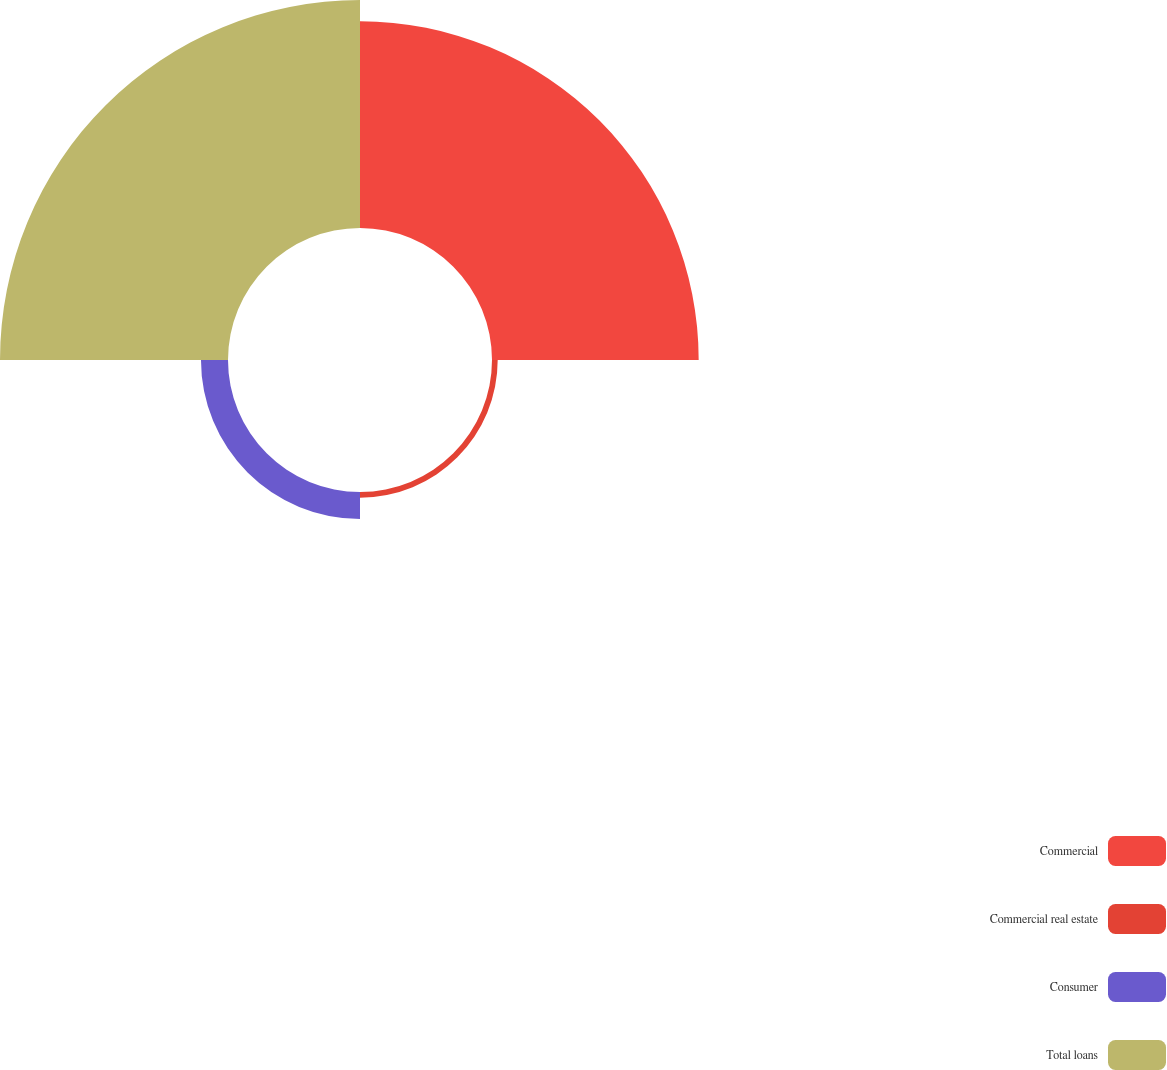<chart> <loc_0><loc_0><loc_500><loc_500><pie_chart><fcel>Commercial<fcel>Commercial real estate<fcel>Consumer<fcel>Total loans<nl><fcel>44.22%<fcel>1.22%<fcel>5.78%<fcel>48.78%<nl></chart> 